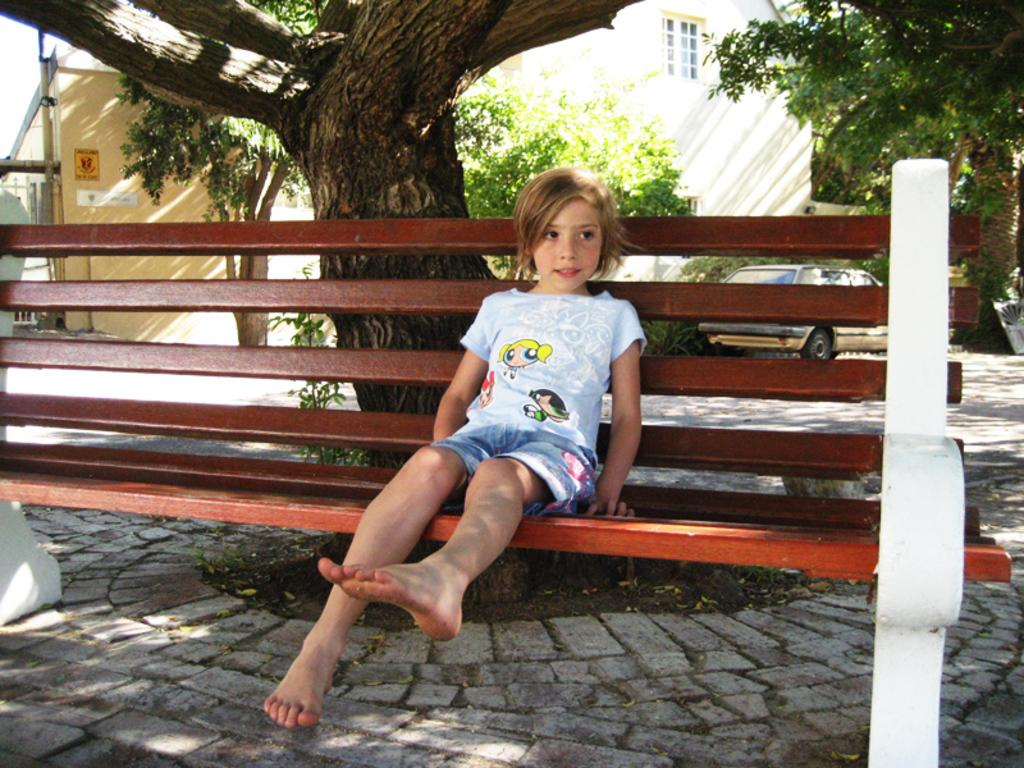What is the girl doing in the image? The girl is sitting on a bench in the image. What can be observed about the girl's feet? The girl has bare feet. What is located behind the girl in the image? There is a tree and a building behind the girl in the image. What type of vehicle is parked on the road in the image? A car is parked on the road in the image. What material is the floor made of in the image? The floor is made of cobblestones. What type of bridge can be seen in the image? There is no bridge present in the image. Is the girl wearing a crown in the image? The girl is not wearing a crown in the image. 